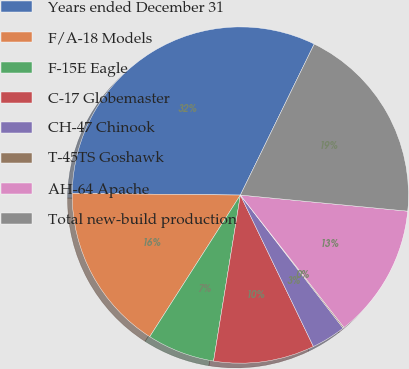Convert chart to OTSL. <chart><loc_0><loc_0><loc_500><loc_500><pie_chart><fcel>Years ended December 31<fcel>F/A-18 Models<fcel>F-15E Eagle<fcel>C-17 Globemaster<fcel>CH-47 Chinook<fcel>T-45TS Goshawk<fcel>AH-64 Apache<fcel>Total new-build production<nl><fcel>32.08%<fcel>16.1%<fcel>6.51%<fcel>9.7%<fcel>3.31%<fcel>0.11%<fcel>12.9%<fcel>19.29%<nl></chart> 